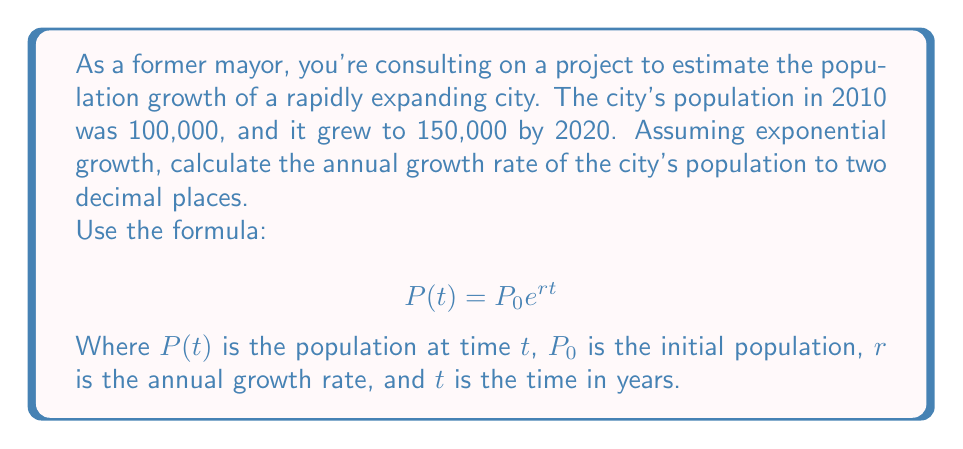Help me with this question. Let's approach this step-by-step:

1) We're given:
   $P_0 = 100,000$ (initial population in 2010)
   $P(t) = 150,000$ (population after 10 years)
   $t = 10$ years

2) We need to find $r$. Let's substitute these values into the formula:

   $$ 150,000 = 100,000 e^{r(10)} $$

3) Divide both sides by 100,000:

   $$ 1.5 = e^{10r} $$

4) Take the natural logarithm of both sides:

   $$ \ln(1.5) = \ln(e^{10r}) $$

5) Using the logarithm property $\ln(e^x) = x$:

   $$ \ln(1.5) = 10r $$

6) Solve for $r$:

   $$ r = \frac{\ln(1.5)}{10} $$

7) Calculate this value:

   $$ r = \frac{0.4054651081}{10} = 0.04054651081 $$

8) Convert to a percentage and round to two decimal places:

   $$ r \approx 4.05\% $$
Answer: The annual population growth rate is approximately 4.05%. 